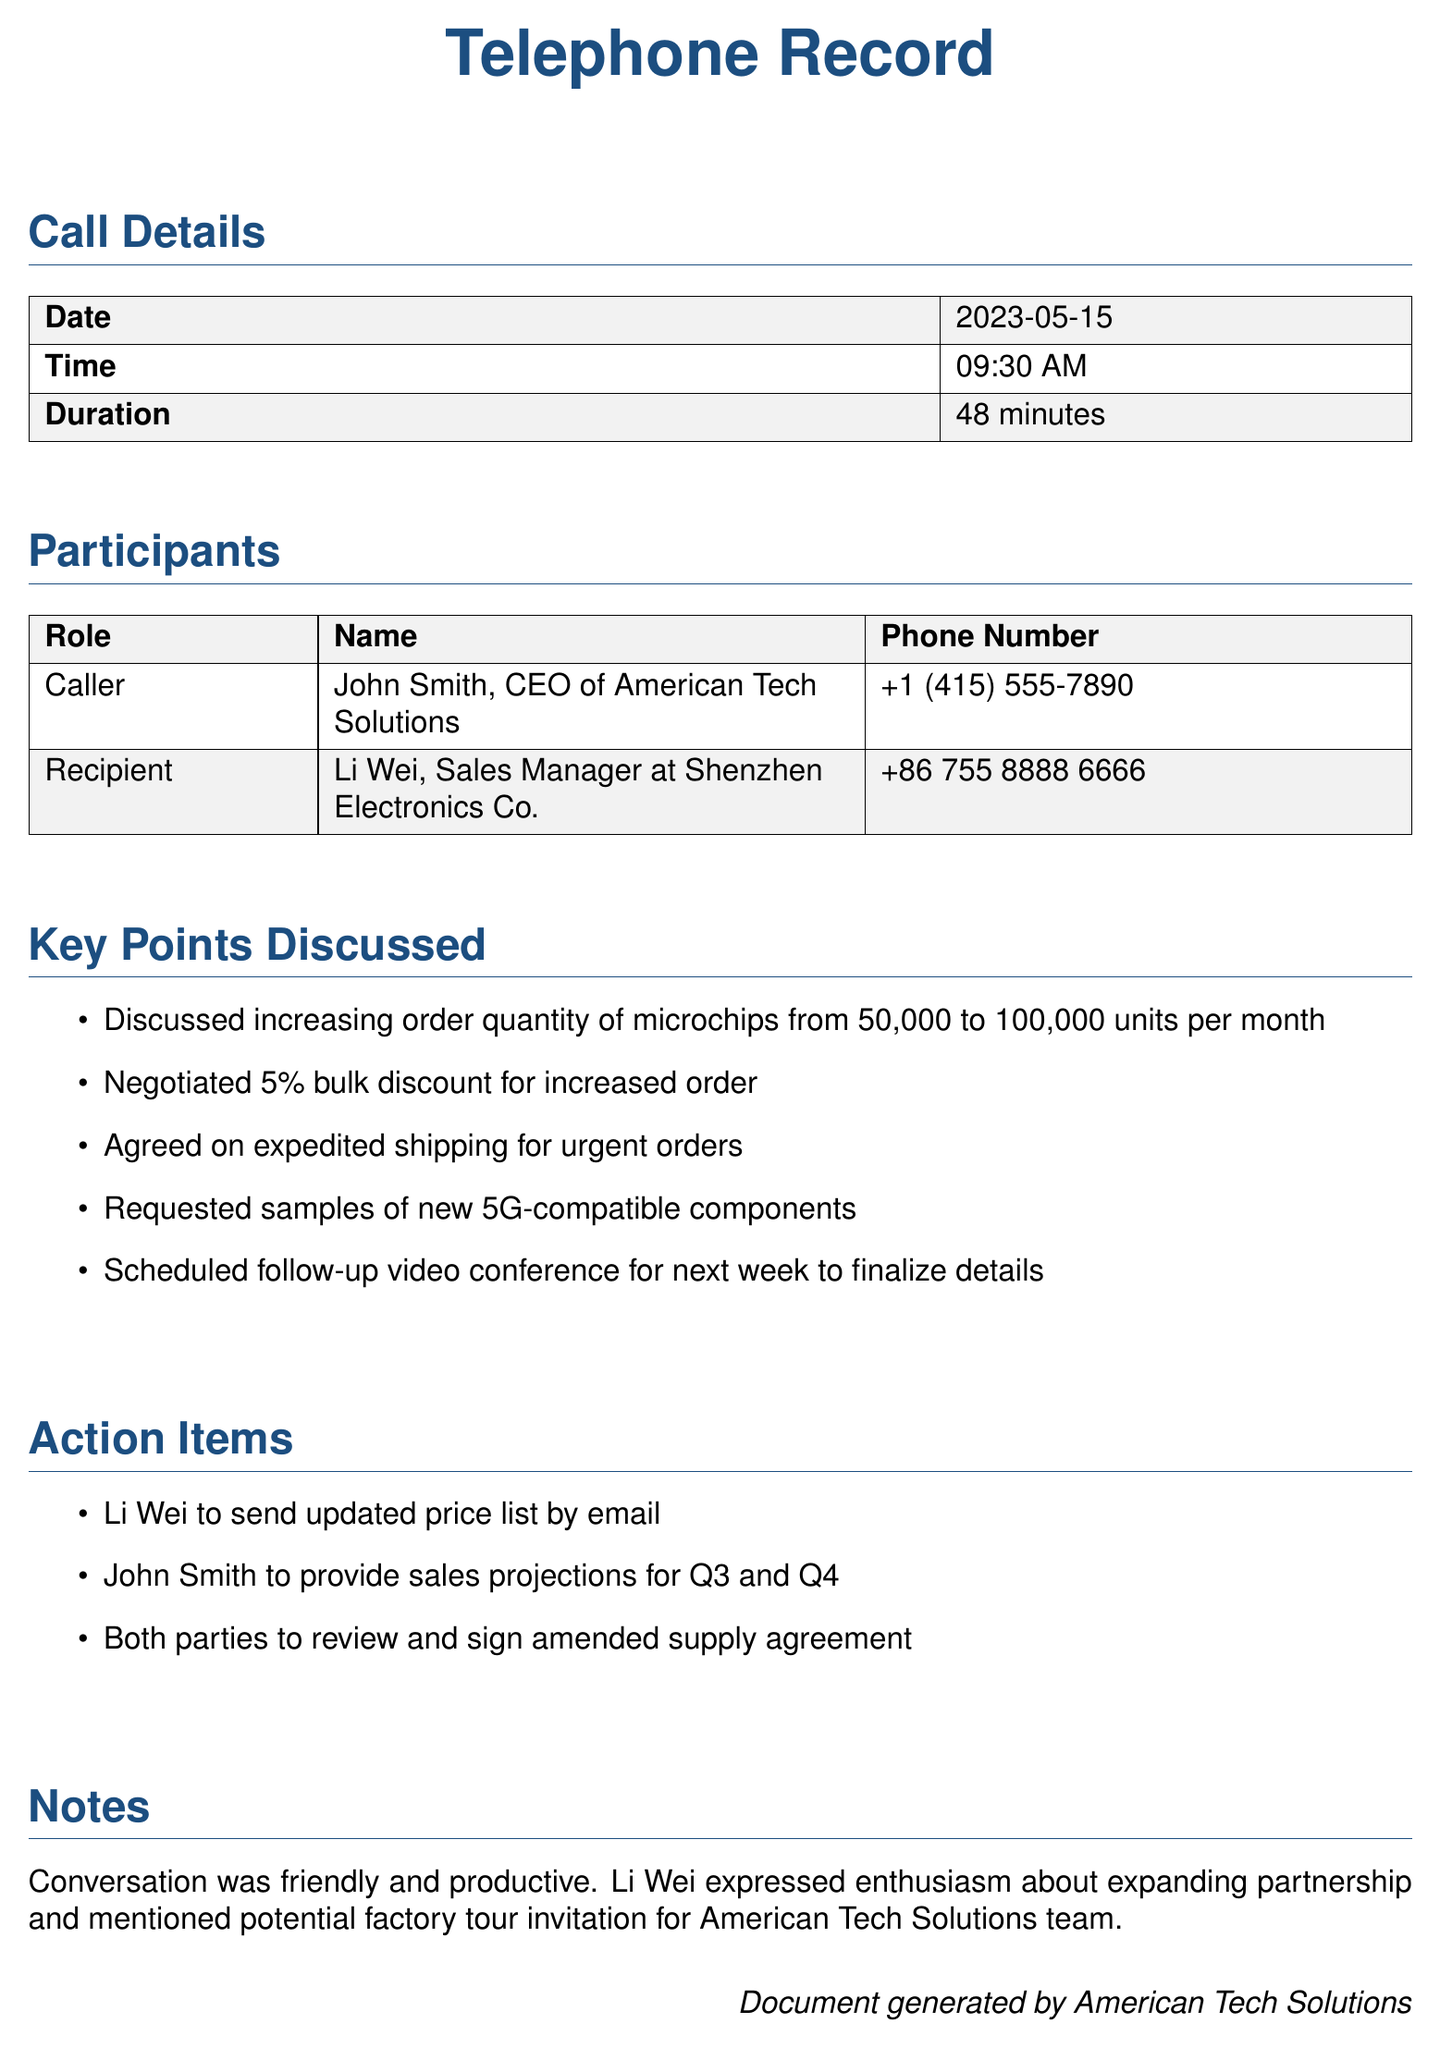what is the date of the call? The date of the call is provided in the call details section of the document.
Answer: 2023-05-15 who is the caller? The caller's name and title are listed under participants in the document.
Answer: John Smith, CEO of American Tech Solutions what was the original order quantity discussed? The original order quantity is mentioned in the key points discussed section.
Answer: 50,000 units what discount was negotiated? The negotiated discount is specified in the key points discussed section.
Answer: 5% bulk discount what is the duration of the call? The duration of the call is detailed in the call details section of the document.
Answer: 48 minutes what will Li Wei send by email? The action items section states what Li Wei will send.
Answer: updated price list how many units per month are they agreeing to order? This information is found in the key points discussed section of the document.
Answer: 100,000 units what was the nature of the conversation? The nature of the conversation is summarized in the notes section of the document.
Answer: friendly and productive when is the follow-up video conference scheduled? The follow-up video conference is mentioned in the key points discussed section but does not specify an exact date.
Answer: next week 